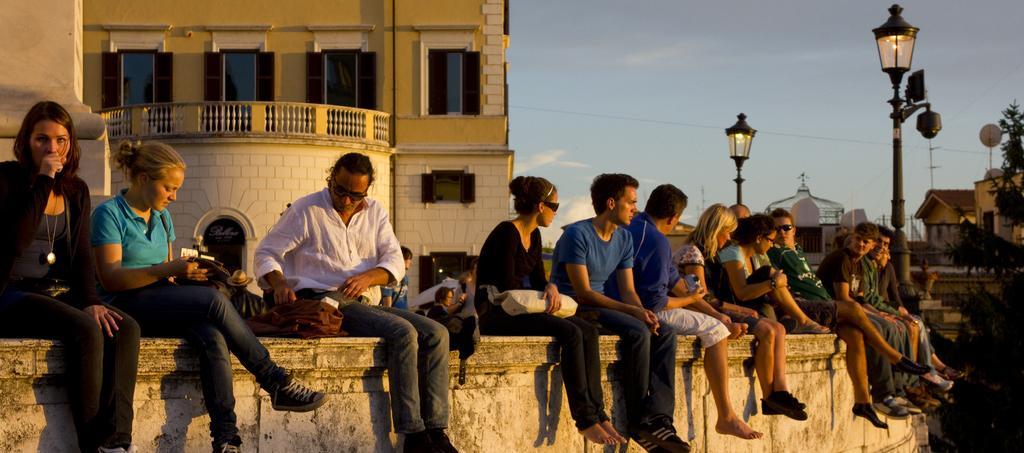Can you describe this image briefly? In this image we can see people sitting on the wall, street poles, street lights, trees, buildings and sky with clouds. 